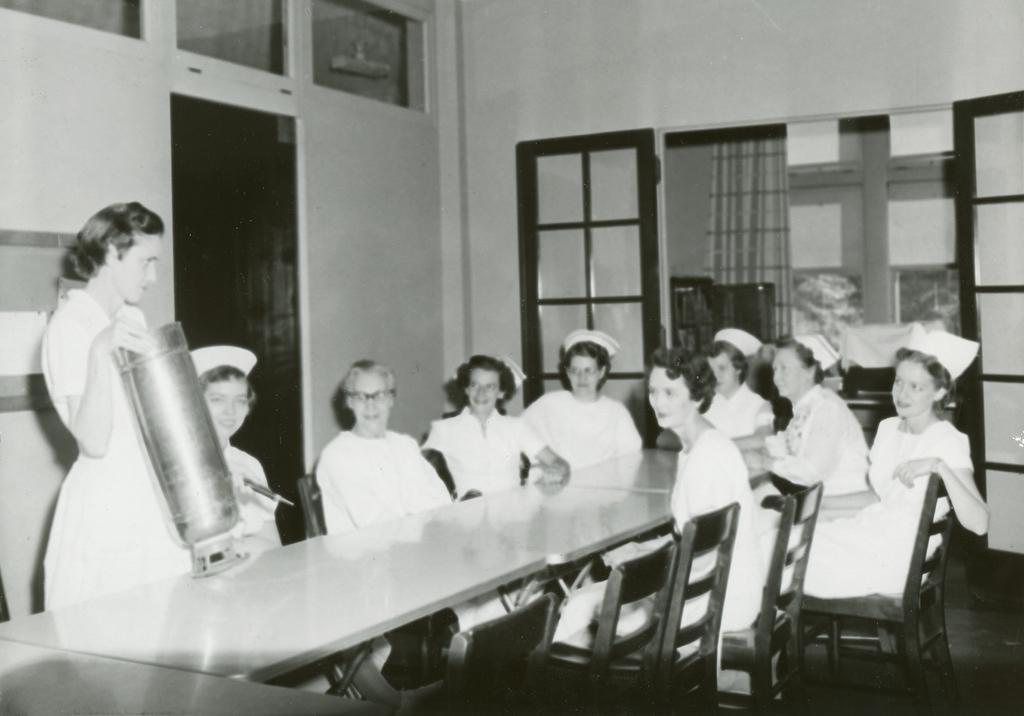Describe this image in one or two sentences. In this picture I can see few people are sitting in the chairs and I can see a woman standing and holding something in her hand and I can see glass doors and tables and I can see a flower pot on the table. 